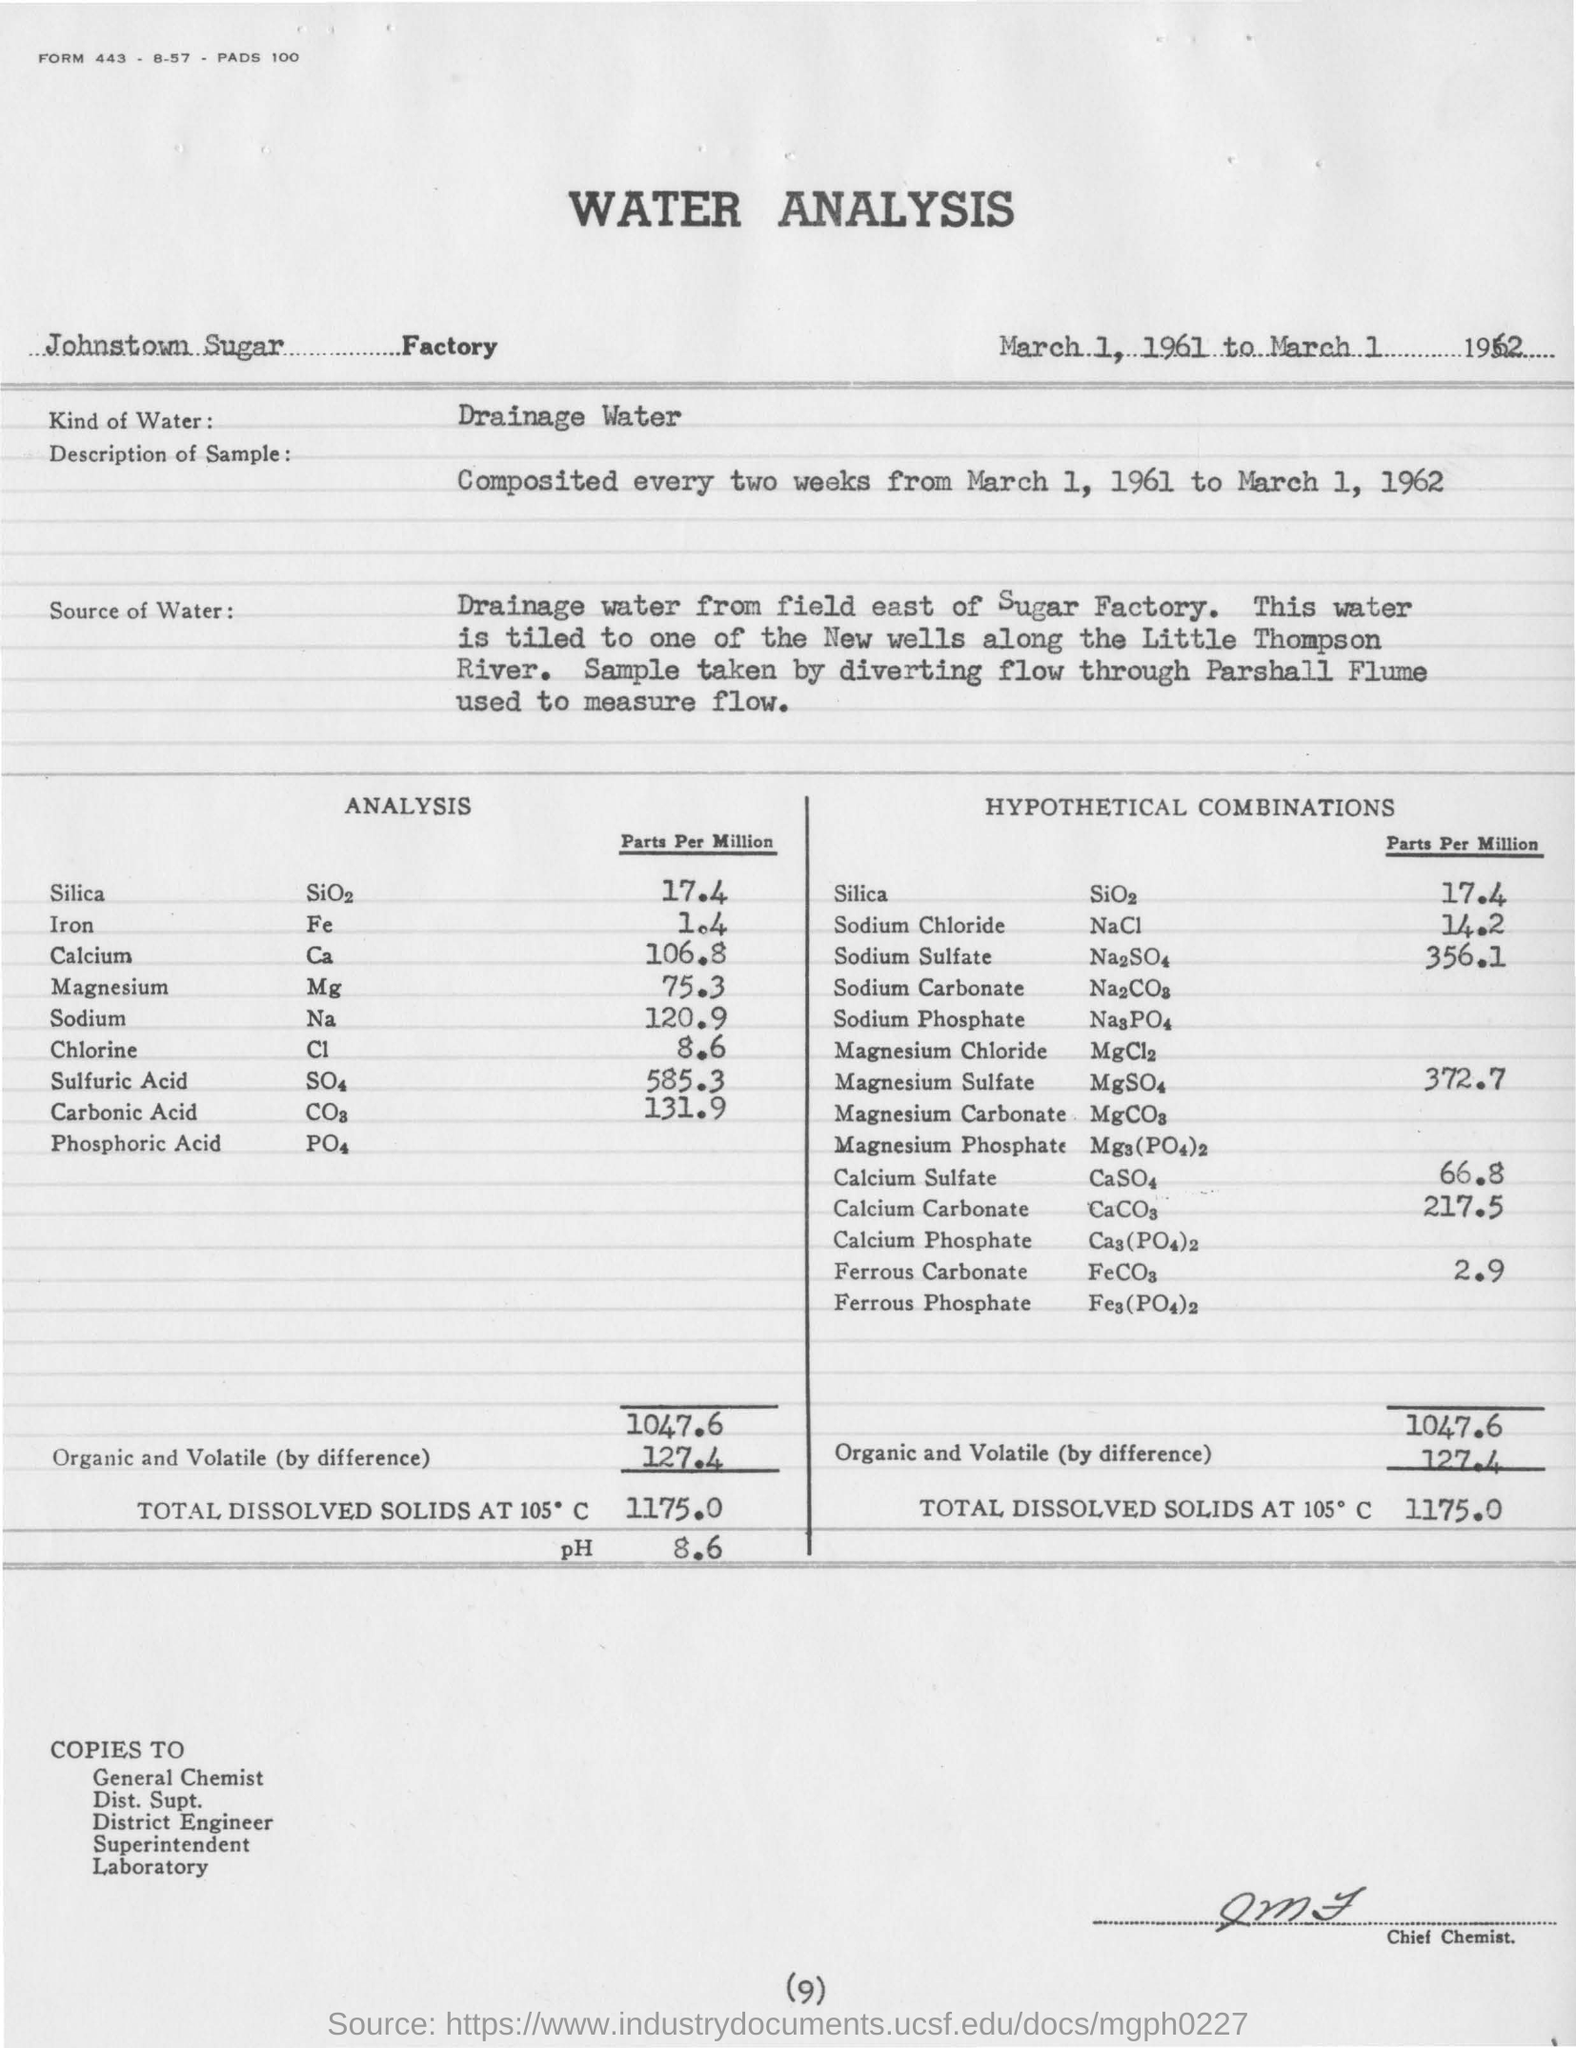Give some essential details in this illustration. The sample taken was described as being composed of data collected every two weeks from March 1, 1961 to March 1, 1962. The concentration of Fe in the sample is 1.4 parts per million. The volume of Magnesium Sulfate (Parts per Million) in the sample is 372.7... The volume of Chlorine (Parts per Million) in the sample is 8.6. The page number mentioned in this document is (9).. 